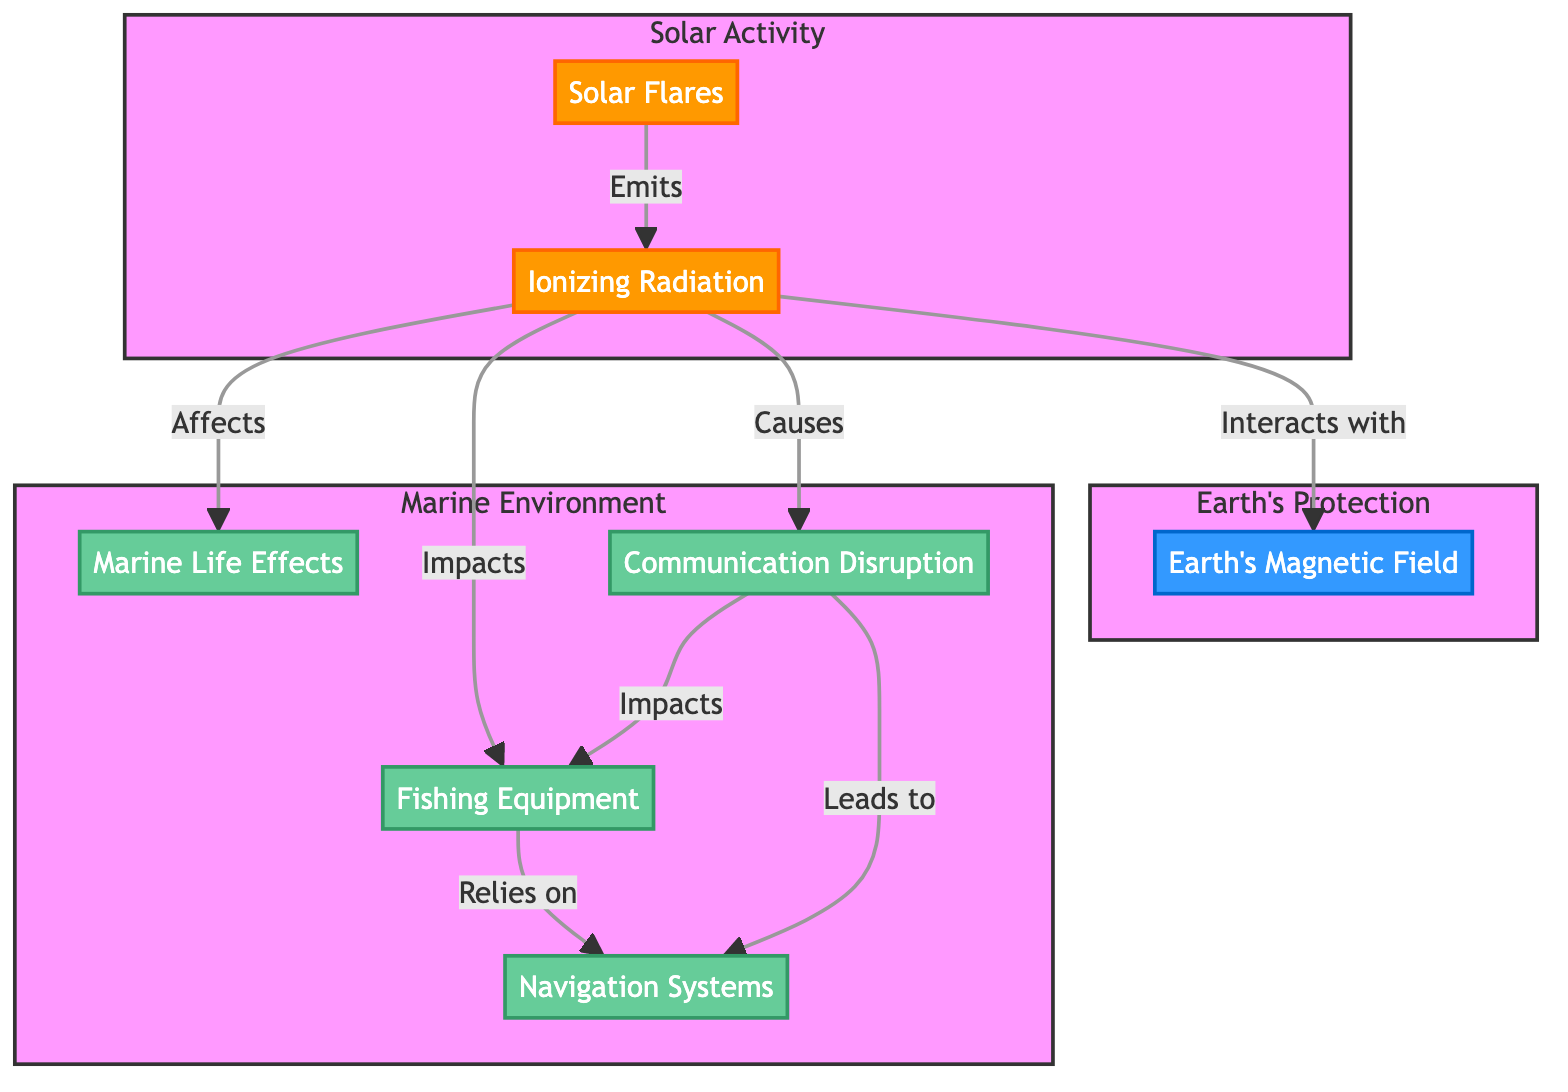What is emitted by solar flares? The diagram indicates that solar flares emit ionizing radiation, as shown by the arrow from Solar Flares to Ionizing Radiation.
Answer: Ionizing radiation How many main subgraphs are present in the diagram? There are three main subgraphs indicated in the diagram: Solar Activity, Earth's Protection, and Marine Environment. Counting these provides a total of three.
Answer: 3 What effect does ionizing radiation have on marine life? The diagram shows an arrow from Ionizing Radiation to Marine Life Effects, indicating that ionizing radiation directly affects marine life.
Answer: Affects Which system relies on fishing equipment according to the diagram? The diagram illustrates that navigation systems rely on fishing equipment, as indicated by the arrow going from Fishing Equipment to Navigation Systems.
Answer: Navigation systems What connects ionizing radiation to communication disruption? The arrow in the diagram shows that ionizing radiation causes communication disruption, connecting the two through an impactful relationship.
Answer: Causes How are fishing equipment and navigation systems related based on the diagram? The diagram shows that fishing equipment relies on navigation systems and communication disruption leads to impacts on fishing equipment. This indicates a mutual dependency.
Answer: Relies on What is the role of Earth's magnetic field in the diagram? Earth's magnetic field is depicted as a protective element that interacts with ionizing radiation, which suggests its role is to shield Earth from the effects of such radiation.
Answer: Protection What are two potential impacts of solar flares on the marine environment? The diagram indicates that solar flares can affect marine life and fishing equipment. This specifies two direct impacts outlined in the connections of the marine environment subgraph.
Answer: Marine life, fishing equipment What happens to navigation systems during communication disruption? The arrow from communication disruption to navigation systems in the diagram indicates that the systems are impacted as a direct consequence of the disruption.
Answer: Impacts 